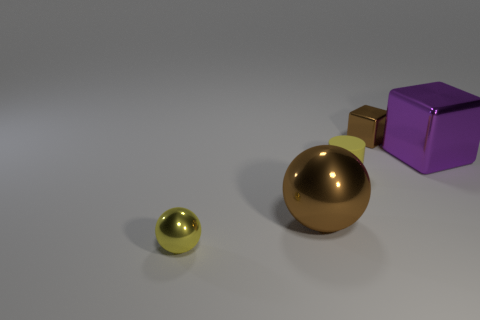Add 1 tiny balls. How many objects exist? 6 Subtract all cylinders. How many objects are left? 4 Add 1 big green matte spheres. How many big green matte spheres exist? 1 Subtract 0 blue blocks. How many objects are left? 5 Subtract all yellow matte cylinders. Subtract all large yellow metal things. How many objects are left? 4 Add 5 purple shiny cubes. How many purple shiny cubes are left? 6 